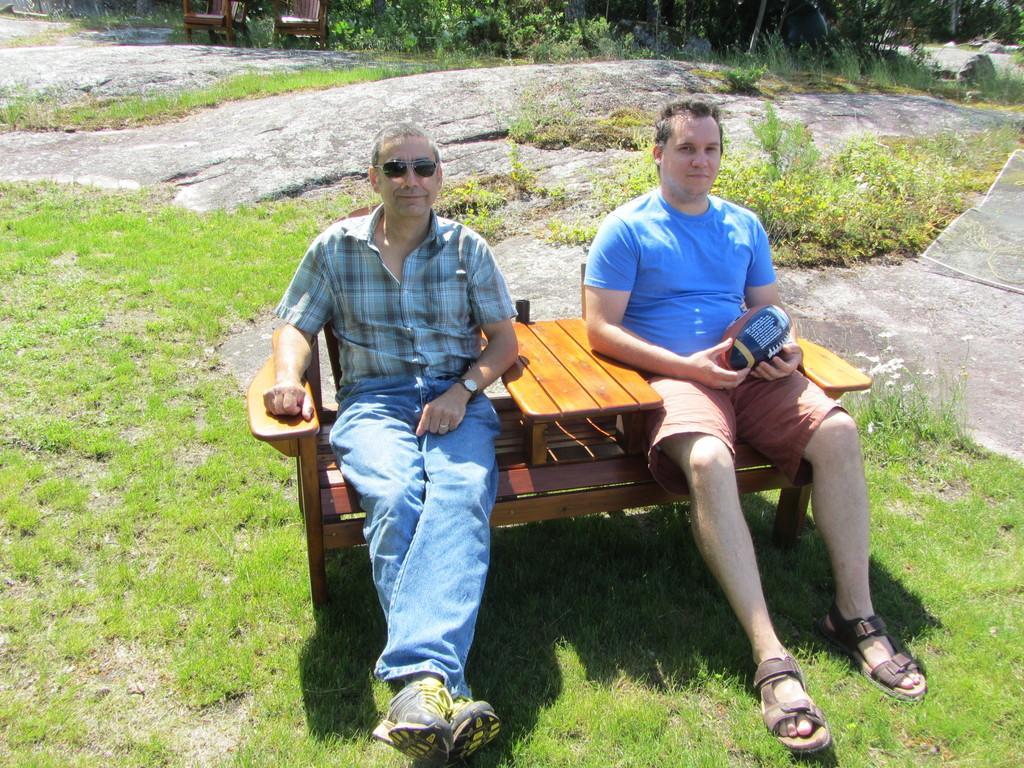In one or two sentences, can you explain what this image depicts? In the foreground of this image, there are two men sitting on chair. Around them there are grass, plants, trees and two chairs in the background. 